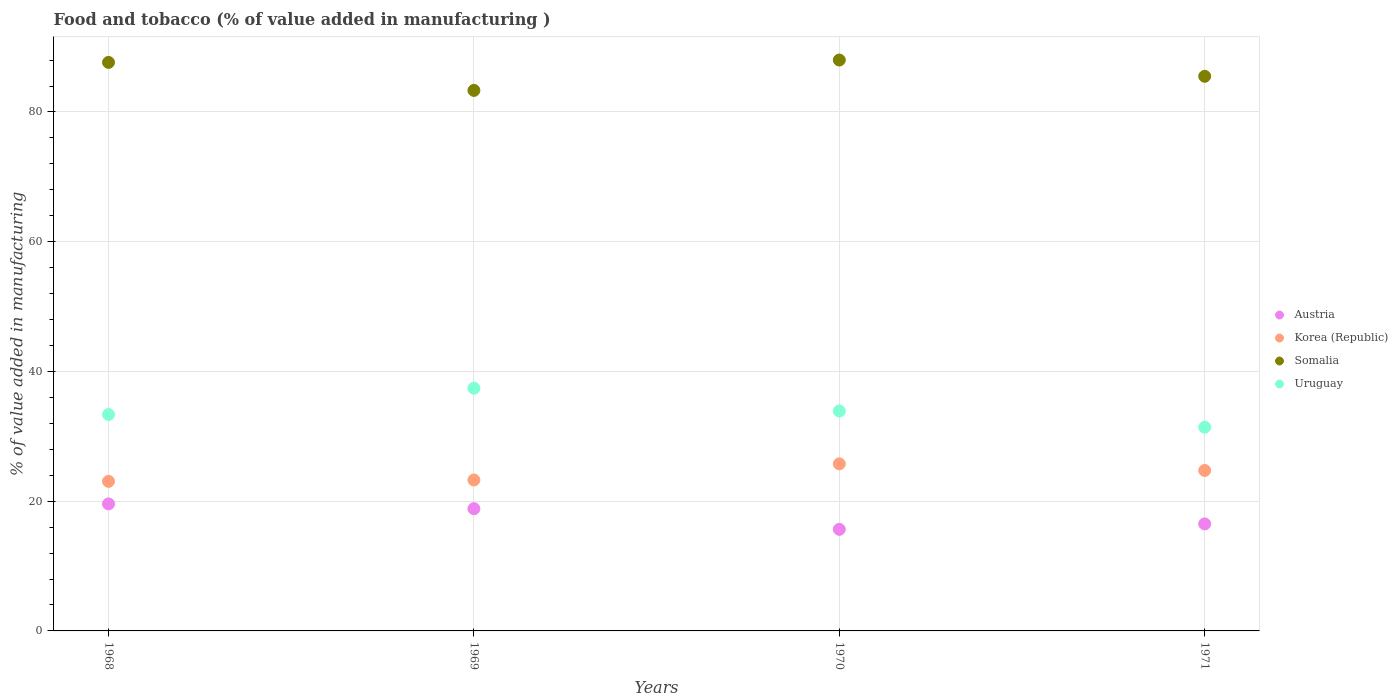How many different coloured dotlines are there?
Provide a succinct answer. 4. Is the number of dotlines equal to the number of legend labels?
Your response must be concise. Yes. What is the value added in manufacturing food and tobacco in Somalia in 1971?
Offer a terse response. 85.5. Across all years, what is the maximum value added in manufacturing food and tobacco in Austria?
Provide a succinct answer. 19.58. Across all years, what is the minimum value added in manufacturing food and tobacco in Korea (Republic)?
Your answer should be compact. 23.06. In which year was the value added in manufacturing food and tobacco in Korea (Republic) maximum?
Provide a succinct answer. 1970. In which year was the value added in manufacturing food and tobacco in Somalia minimum?
Keep it short and to the point. 1969. What is the total value added in manufacturing food and tobacco in Austria in the graph?
Offer a terse response. 70.59. What is the difference between the value added in manufacturing food and tobacco in Uruguay in 1968 and that in 1971?
Your response must be concise. 1.96. What is the difference between the value added in manufacturing food and tobacco in Austria in 1971 and the value added in manufacturing food and tobacco in Korea (Republic) in 1970?
Give a very brief answer. -9.25. What is the average value added in manufacturing food and tobacco in Somalia per year?
Provide a succinct answer. 86.12. In the year 1970, what is the difference between the value added in manufacturing food and tobacco in Korea (Republic) and value added in manufacturing food and tobacco in Austria?
Your answer should be compact. 10.09. What is the ratio of the value added in manufacturing food and tobacco in Somalia in 1968 to that in 1969?
Your answer should be compact. 1.05. What is the difference between the highest and the second highest value added in manufacturing food and tobacco in Uruguay?
Your answer should be very brief. 3.52. What is the difference between the highest and the lowest value added in manufacturing food and tobacco in Uruguay?
Ensure brevity in your answer.  6.01. In how many years, is the value added in manufacturing food and tobacco in Austria greater than the average value added in manufacturing food and tobacco in Austria taken over all years?
Your answer should be compact. 2. Is the sum of the value added in manufacturing food and tobacco in Austria in 1968 and 1969 greater than the maximum value added in manufacturing food and tobacco in Somalia across all years?
Give a very brief answer. No. Is it the case that in every year, the sum of the value added in manufacturing food and tobacco in Korea (Republic) and value added in manufacturing food and tobacco in Somalia  is greater than the sum of value added in manufacturing food and tobacco in Austria and value added in manufacturing food and tobacco in Uruguay?
Your answer should be compact. Yes. Does the value added in manufacturing food and tobacco in Korea (Republic) monotonically increase over the years?
Your answer should be compact. No. How many years are there in the graph?
Offer a terse response. 4. What is the difference between two consecutive major ticks on the Y-axis?
Your answer should be compact. 20. Are the values on the major ticks of Y-axis written in scientific E-notation?
Keep it short and to the point. No. Does the graph contain any zero values?
Provide a short and direct response. No. How are the legend labels stacked?
Offer a very short reply. Vertical. What is the title of the graph?
Keep it short and to the point. Food and tobacco (% of value added in manufacturing ). What is the label or title of the X-axis?
Ensure brevity in your answer.  Years. What is the label or title of the Y-axis?
Provide a short and direct response. % of value added in manufacturing. What is the % of value added in manufacturing of Austria in 1968?
Offer a very short reply. 19.58. What is the % of value added in manufacturing in Korea (Republic) in 1968?
Make the answer very short. 23.06. What is the % of value added in manufacturing of Somalia in 1968?
Provide a succinct answer. 87.64. What is the % of value added in manufacturing in Uruguay in 1968?
Make the answer very short. 33.36. What is the % of value added in manufacturing of Austria in 1969?
Offer a terse response. 18.85. What is the % of value added in manufacturing of Korea (Republic) in 1969?
Your answer should be compact. 23.27. What is the % of value added in manufacturing of Somalia in 1969?
Provide a short and direct response. 83.33. What is the % of value added in manufacturing of Uruguay in 1969?
Make the answer very short. 37.42. What is the % of value added in manufacturing in Austria in 1970?
Provide a succinct answer. 15.66. What is the % of value added in manufacturing in Korea (Republic) in 1970?
Give a very brief answer. 25.75. What is the % of value added in manufacturing in Somalia in 1970?
Make the answer very short. 88.01. What is the % of value added in manufacturing in Uruguay in 1970?
Offer a terse response. 33.9. What is the % of value added in manufacturing of Austria in 1971?
Your response must be concise. 16.5. What is the % of value added in manufacturing of Korea (Republic) in 1971?
Give a very brief answer. 24.74. What is the % of value added in manufacturing of Somalia in 1971?
Offer a very short reply. 85.5. What is the % of value added in manufacturing of Uruguay in 1971?
Provide a short and direct response. 31.4. Across all years, what is the maximum % of value added in manufacturing in Austria?
Offer a terse response. 19.58. Across all years, what is the maximum % of value added in manufacturing in Korea (Republic)?
Your response must be concise. 25.75. Across all years, what is the maximum % of value added in manufacturing in Somalia?
Give a very brief answer. 88.01. Across all years, what is the maximum % of value added in manufacturing in Uruguay?
Your answer should be very brief. 37.42. Across all years, what is the minimum % of value added in manufacturing of Austria?
Provide a succinct answer. 15.66. Across all years, what is the minimum % of value added in manufacturing of Korea (Republic)?
Offer a very short reply. 23.06. Across all years, what is the minimum % of value added in manufacturing of Somalia?
Provide a succinct answer. 83.33. Across all years, what is the minimum % of value added in manufacturing in Uruguay?
Offer a terse response. 31.4. What is the total % of value added in manufacturing in Austria in the graph?
Make the answer very short. 70.59. What is the total % of value added in manufacturing of Korea (Republic) in the graph?
Make the answer very short. 96.82. What is the total % of value added in manufacturing of Somalia in the graph?
Provide a short and direct response. 344.48. What is the total % of value added in manufacturing of Uruguay in the graph?
Offer a very short reply. 136.08. What is the difference between the % of value added in manufacturing in Austria in 1968 and that in 1969?
Your response must be concise. 0.74. What is the difference between the % of value added in manufacturing of Korea (Republic) in 1968 and that in 1969?
Provide a short and direct response. -0.21. What is the difference between the % of value added in manufacturing of Somalia in 1968 and that in 1969?
Your answer should be compact. 4.32. What is the difference between the % of value added in manufacturing in Uruguay in 1968 and that in 1969?
Your response must be concise. -4.05. What is the difference between the % of value added in manufacturing of Austria in 1968 and that in 1970?
Offer a terse response. 3.92. What is the difference between the % of value added in manufacturing in Korea (Republic) in 1968 and that in 1970?
Your response must be concise. -2.69. What is the difference between the % of value added in manufacturing of Somalia in 1968 and that in 1970?
Ensure brevity in your answer.  -0.36. What is the difference between the % of value added in manufacturing in Uruguay in 1968 and that in 1970?
Offer a very short reply. -0.53. What is the difference between the % of value added in manufacturing in Austria in 1968 and that in 1971?
Offer a very short reply. 3.08. What is the difference between the % of value added in manufacturing in Korea (Republic) in 1968 and that in 1971?
Your response must be concise. -1.68. What is the difference between the % of value added in manufacturing of Somalia in 1968 and that in 1971?
Provide a short and direct response. 2.14. What is the difference between the % of value added in manufacturing in Uruguay in 1968 and that in 1971?
Make the answer very short. 1.96. What is the difference between the % of value added in manufacturing of Austria in 1969 and that in 1970?
Keep it short and to the point. 3.19. What is the difference between the % of value added in manufacturing in Korea (Republic) in 1969 and that in 1970?
Keep it short and to the point. -2.49. What is the difference between the % of value added in manufacturing in Somalia in 1969 and that in 1970?
Offer a terse response. -4.68. What is the difference between the % of value added in manufacturing in Uruguay in 1969 and that in 1970?
Offer a very short reply. 3.52. What is the difference between the % of value added in manufacturing in Austria in 1969 and that in 1971?
Your answer should be very brief. 2.34. What is the difference between the % of value added in manufacturing of Korea (Republic) in 1969 and that in 1971?
Your response must be concise. -1.47. What is the difference between the % of value added in manufacturing of Somalia in 1969 and that in 1971?
Make the answer very short. -2.17. What is the difference between the % of value added in manufacturing of Uruguay in 1969 and that in 1971?
Offer a terse response. 6.01. What is the difference between the % of value added in manufacturing of Austria in 1970 and that in 1971?
Give a very brief answer. -0.84. What is the difference between the % of value added in manufacturing of Korea (Republic) in 1970 and that in 1971?
Keep it short and to the point. 1.01. What is the difference between the % of value added in manufacturing in Somalia in 1970 and that in 1971?
Keep it short and to the point. 2.51. What is the difference between the % of value added in manufacturing in Uruguay in 1970 and that in 1971?
Give a very brief answer. 2.5. What is the difference between the % of value added in manufacturing of Austria in 1968 and the % of value added in manufacturing of Korea (Republic) in 1969?
Your response must be concise. -3.69. What is the difference between the % of value added in manufacturing in Austria in 1968 and the % of value added in manufacturing in Somalia in 1969?
Your response must be concise. -63.74. What is the difference between the % of value added in manufacturing in Austria in 1968 and the % of value added in manufacturing in Uruguay in 1969?
Give a very brief answer. -17.83. What is the difference between the % of value added in manufacturing in Korea (Republic) in 1968 and the % of value added in manufacturing in Somalia in 1969?
Provide a short and direct response. -60.27. What is the difference between the % of value added in manufacturing of Korea (Republic) in 1968 and the % of value added in manufacturing of Uruguay in 1969?
Ensure brevity in your answer.  -14.36. What is the difference between the % of value added in manufacturing of Somalia in 1968 and the % of value added in manufacturing of Uruguay in 1969?
Provide a succinct answer. 50.23. What is the difference between the % of value added in manufacturing in Austria in 1968 and the % of value added in manufacturing in Korea (Republic) in 1970?
Give a very brief answer. -6.17. What is the difference between the % of value added in manufacturing in Austria in 1968 and the % of value added in manufacturing in Somalia in 1970?
Provide a succinct answer. -68.43. What is the difference between the % of value added in manufacturing in Austria in 1968 and the % of value added in manufacturing in Uruguay in 1970?
Offer a very short reply. -14.32. What is the difference between the % of value added in manufacturing in Korea (Republic) in 1968 and the % of value added in manufacturing in Somalia in 1970?
Give a very brief answer. -64.95. What is the difference between the % of value added in manufacturing of Korea (Republic) in 1968 and the % of value added in manufacturing of Uruguay in 1970?
Your response must be concise. -10.84. What is the difference between the % of value added in manufacturing of Somalia in 1968 and the % of value added in manufacturing of Uruguay in 1970?
Keep it short and to the point. 53.75. What is the difference between the % of value added in manufacturing of Austria in 1968 and the % of value added in manufacturing of Korea (Republic) in 1971?
Your answer should be very brief. -5.16. What is the difference between the % of value added in manufacturing in Austria in 1968 and the % of value added in manufacturing in Somalia in 1971?
Make the answer very short. -65.92. What is the difference between the % of value added in manufacturing in Austria in 1968 and the % of value added in manufacturing in Uruguay in 1971?
Make the answer very short. -11.82. What is the difference between the % of value added in manufacturing in Korea (Republic) in 1968 and the % of value added in manufacturing in Somalia in 1971?
Keep it short and to the point. -62.44. What is the difference between the % of value added in manufacturing of Korea (Republic) in 1968 and the % of value added in manufacturing of Uruguay in 1971?
Make the answer very short. -8.34. What is the difference between the % of value added in manufacturing of Somalia in 1968 and the % of value added in manufacturing of Uruguay in 1971?
Keep it short and to the point. 56.24. What is the difference between the % of value added in manufacturing of Austria in 1969 and the % of value added in manufacturing of Korea (Republic) in 1970?
Give a very brief answer. -6.91. What is the difference between the % of value added in manufacturing in Austria in 1969 and the % of value added in manufacturing in Somalia in 1970?
Make the answer very short. -69.16. What is the difference between the % of value added in manufacturing in Austria in 1969 and the % of value added in manufacturing in Uruguay in 1970?
Give a very brief answer. -15.05. What is the difference between the % of value added in manufacturing of Korea (Republic) in 1969 and the % of value added in manufacturing of Somalia in 1970?
Provide a succinct answer. -64.74. What is the difference between the % of value added in manufacturing of Korea (Republic) in 1969 and the % of value added in manufacturing of Uruguay in 1970?
Ensure brevity in your answer.  -10.63. What is the difference between the % of value added in manufacturing in Somalia in 1969 and the % of value added in manufacturing in Uruguay in 1970?
Your answer should be compact. 49.43. What is the difference between the % of value added in manufacturing of Austria in 1969 and the % of value added in manufacturing of Korea (Republic) in 1971?
Your response must be concise. -5.89. What is the difference between the % of value added in manufacturing of Austria in 1969 and the % of value added in manufacturing of Somalia in 1971?
Your answer should be very brief. -66.66. What is the difference between the % of value added in manufacturing of Austria in 1969 and the % of value added in manufacturing of Uruguay in 1971?
Keep it short and to the point. -12.56. What is the difference between the % of value added in manufacturing in Korea (Republic) in 1969 and the % of value added in manufacturing in Somalia in 1971?
Offer a terse response. -62.23. What is the difference between the % of value added in manufacturing in Korea (Republic) in 1969 and the % of value added in manufacturing in Uruguay in 1971?
Provide a short and direct response. -8.14. What is the difference between the % of value added in manufacturing in Somalia in 1969 and the % of value added in manufacturing in Uruguay in 1971?
Offer a very short reply. 51.92. What is the difference between the % of value added in manufacturing of Austria in 1970 and the % of value added in manufacturing of Korea (Republic) in 1971?
Keep it short and to the point. -9.08. What is the difference between the % of value added in manufacturing of Austria in 1970 and the % of value added in manufacturing of Somalia in 1971?
Offer a terse response. -69.84. What is the difference between the % of value added in manufacturing in Austria in 1970 and the % of value added in manufacturing in Uruguay in 1971?
Offer a very short reply. -15.74. What is the difference between the % of value added in manufacturing in Korea (Republic) in 1970 and the % of value added in manufacturing in Somalia in 1971?
Your answer should be very brief. -59.75. What is the difference between the % of value added in manufacturing of Korea (Republic) in 1970 and the % of value added in manufacturing of Uruguay in 1971?
Your answer should be very brief. -5.65. What is the difference between the % of value added in manufacturing in Somalia in 1970 and the % of value added in manufacturing in Uruguay in 1971?
Give a very brief answer. 56.6. What is the average % of value added in manufacturing in Austria per year?
Your answer should be very brief. 17.65. What is the average % of value added in manufacturing in Korea (Republic) per year?
Provide a succinct answer. 24.2. What is the average % of value added in manufacturing in Somalia per year?
Make the answer very short. 86.12. What is the average % of value added in manufacturing in Uruguay per year?
Offer a terse response. 34.02. In the year 1968, what is the difference between the % of value added in manufacturing of Austria and % of value added in manufacturing of Korea (Republic)?
Your answer should be compact. -3.48. In the year 1968, what is the difference between the % of value added in manufacturing of Austria and % of value added in manufacturing of Somalia?
Ensure brevity in your answer.  -68.06. In the year 1968, what is the difference between the % of value added in manufacturing in Austria and % of value added in manufacturing in Uruguay?
Offer a very short reply. -13.78. In the year 1968, what is the difference between the % of value added in manufacturing in Korea (Republic) and % of value added in manufacturing in Somalia?
Provide a short and direct response. -64.59. In the year 1968, what is the difference between the % of value added in manufacturing of Korea (Republic) and % of value added in manufacturing of Uruguay?
Ensure brevity in your answer.  -10.3. In the year 1968, what is the difference between the % of value added in manufacturing of Somalia and % of value added in manufacturing of Uruguay?
Give a very brief answer. 54.28. In the year 1969, what is the difference between the % of value added in manufacturing in Austria and % of value added in manufacturing in Korea (Republic)?
Offer a very short reply. -4.42. In the year 1969, what is the difference between the % of value added in manufacturing in Austria and % of value added in manufacturing in Somalia?
Provide a succinct answer. -64.48. In the year 1969, what is the difference between the % of value added in manufacturing of Austria and % of value added in manufacturing of Uruguay?
Offer a very short reply. -18.57. In the year 1969, what is the difference between the % of value added in manufacturing of Korea (Republic) and % of value added in manufacturing of Somalia?
Give a very brief answer. -60.06. In the year 1969, what is the difference between the % of value added in manufacturing in Korea (Republic) and % of value added in manufacturing in Uruguay?
Make the answer very short. -14.15. In the year 1969, what is the difference between the % of value added in manufacturing of Somalia and % of value added in manufacturing of Uruguay?
Ensure brevity in your answer.  45.91. In the year 1970, what is the difference between the % of value added in manufacturing of Austria and % of value added in manufacturing of Korea (Republic)?
Provide a succinct answer. -10.09. In the year 1970, what is the difference between the % of value added in manufacturing of Austria and % of value added in manufacturing of Somalia?
Your answer should be very brief. -72.35. In the year 1970, what is the difference between the % of value added in manufacturing of Austria and % of value added in manufacturing of Uruguay?
Keep it short and to the point. -18.24. In the year 1970, what is the difference between the % of value added in manufacturing of Korea (Republic) and % of value added in manufacturing of Somalia?
Give a very brief answer. -62.25. In the year 1970, what is the difference between the % of value added in manufacturing of Korea (Republic) and % of value added in manufacturing of Uruguay?
Your answer should be very brief. -8.14. In the year 1970, what is the difference between the % of value added in manufacturing of Somalia and % of value added in manufacturing of Uruguay?
Provide a succinct answer. 54.11. In the year 1971, what is the difference between the % of value added in manufacturing of Austria and % of value added in manufacturing of Korea (Republic)?
Your answer should be very brief. -8.24. In the year 1971, what is the difference between the % of value added in manufacturing in Austria and % of value added in manufacturing in Somalia?
Offer a terse response. -69. In the year 1971, what is the difference between the % of value added in manufacturing in Austria and % of value added in manufacturing in Uruguay?
Offer a very short reply. -14.9. In the year 1971, what is the difference between the % of value added in manufacturing of Korea (Republic) and % of value added in manufacturing of Somalia?
Your answer should be very brief. -60.76. In the year 1971, what is the difference between the % of value added in manufacturing in Korea (Republic) and % of value added in manufacturing in Uruguay?
Your response must be concise. -6.66. In the year 1971, what is the difference between the % of value added in manufacturing in Somalia and % of value added in manufacturing in Uruguay?
Make the answer very short. 54.1. What is the ratio of the % of value added in manufacturing of Austria in 1968 to that in 1969?
Give a very brief answer. 1.04. What is the ratio of the % of value added in manufacturing in Korea (Republic) in 1968 to that in 1969?
Provide a succinct answer. 0.99. What is the ratio of the % of value added in manufacturing in Somalia in 1968 to that in 1969?
Offer a very short reply. 1.05. What is the ratio of the % of value added in manufacturing in Uruguay in 1968 to that in 1969?
Give a very brief answer. 0.89. What is the ratio of the % of value added in manufacturing in Austria in 1968 to that in 1970?
Offer a very short reply. 1.25. What is the ratio of the % of value added in manufacturing of Korea (Republic) in 1968 to that in 1970?
Provide a short and direct response. 0.9. What is the ratio of the % of value added in manufacturing in Uruguay in 1968 to that in 1970?
Provide a short and direct response. 0.98. What is the ratio of the % of value added in manufacturing of Austria in 1968 to that in 1971?
Offer a very short reply. 1.19. What is the ratio of the % of value added in manufacturing of Korea (Republic) in 1968 to that in 1971?
Keep it short and to the point. 0.93. What is the ratio of the % of value added in manufacturing of Somalia in 1968 to that in 1971?
Make the answer very short. 1.03. What is the ratio of the % of value added in manufacturing of Uruguay in 1968 to that in 1971?
Provide a short and direct response. 1.06. What is the ratio of the % of value added in manufacturing of Austria in 1969 to that in 1970?
Your response must be concise. 1.2. What is the ratio of the % of value added in manufacturing in Korea (Republic) in 1969 to that in 1970?
Ensure brevity in your answer.  0.9. What is the ratio of the % of value added in manufacturing of Somalia in 1969 to that in 1970?
Offer a very short reply. 0.95. What is the ratio of the % of value added in manufacturing of Uruguay in 1969 to that in 1970?
Your response must be concise. 1.1. What is the ratio of the % of value added in manufacturing in Austria in 1969 to that in 1971?
Offer a terse response. 1.14. What is the ratio of the % of value added in manufacturing in Korea (Republic) in 1969 to that in 1971?
Ensure brevity in your answer.  0.94. What is the ratio of the % of value added in manufacturing of Somalia in 1969 to that in 1971?
Your answer should be very brief. 0.97. What is the ratio of the % of value added in manufacturing in Uruguay in 1969 to that in 1971?
Provide a succinct answer. 1.19. What is the ratio of the % of value added in manufacturing in Austria in 1970 to that in 1971?
Your response must be concise. 0.95. What is the ratio of the % of value added in manufacturing in Korea (Republic) in 1970 to that in 1971?
Keep it short and to the point. 1.04. What is the ratio of the % of value added in manufacturing in Somalia in 1970 to that in 1971?
Provide a succinct answer. 1.03. What is the ratio of the % of value added in manufacturing of Uruguay in 1970 to that in 1971?
Your answer should be very brief. 1.08. What is the difference between the highest and the second highest % of value added in manufacturing of Austria?
Provide a short and direct response. 0.74. What is the difference between the highest and the second highest % of value added in manufacturing of Korea (Republic)?
Give a very brief answer. 1.01. What is the difference between the highest and the second highest % of value added in manufacturing of Somalia?
Keep it short and to the point. 0.36. What is the difference between the highest and the second highest % of value added in manufacturing of Uruguay?
Provide a succinct answer. 3.52. What is the difference between the highest and the lowest % of value added in manufacturing of Austria?
Provide a short and direct response. 3.92. What is the difference between the highest and the lowest % of value added in manufacturing of Korea (Republic)?
Ensure brevity in your answer.  2.69. What is the difference between the highest and the lowest % of value added in manufacturing in Somalia?
Offer a very short reply. 4.68. What is the difference between the highest and the lowest % of value added in manufacturing of Uruguay?
Offer a terse response. 6.01. 